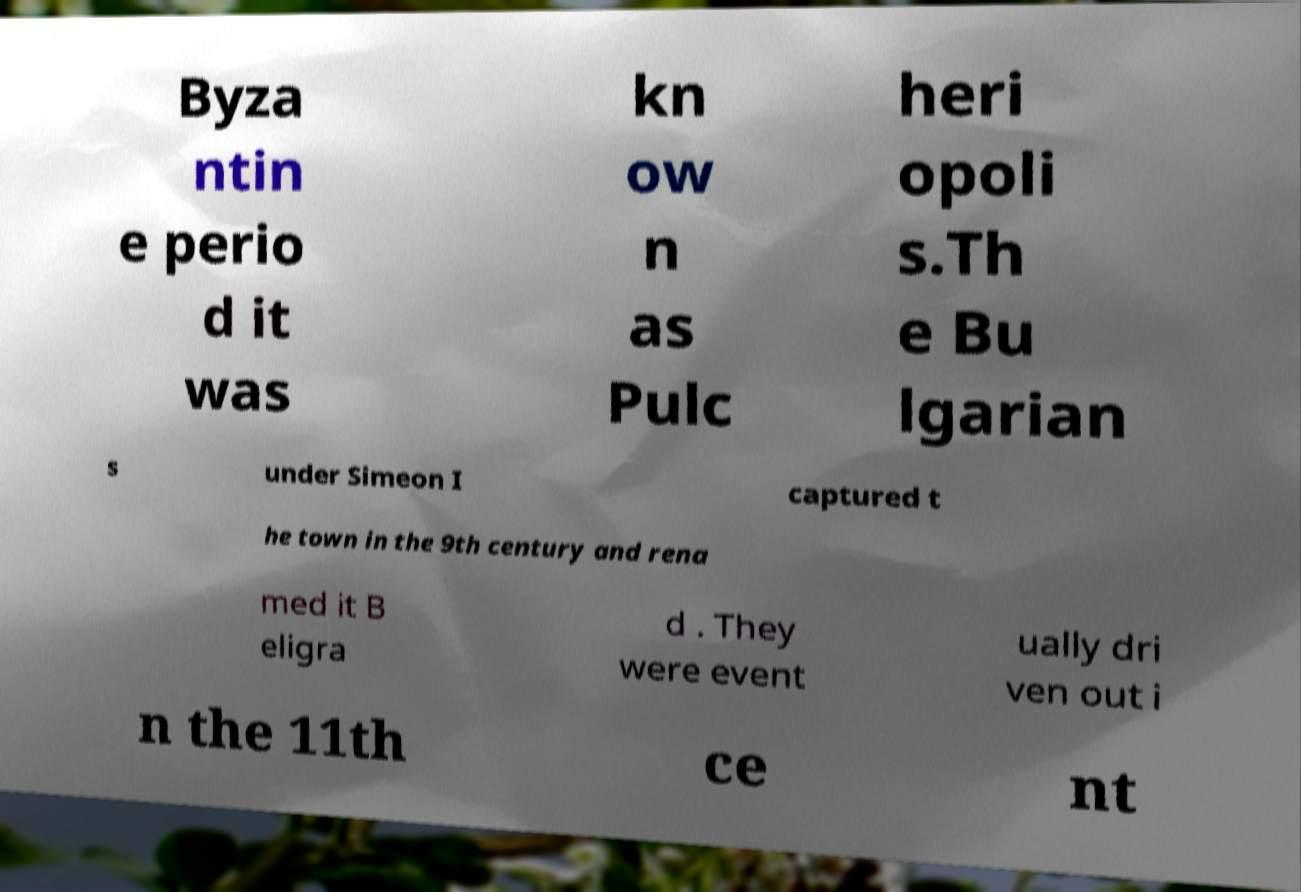Please read and relay the text visible in this image. What does it say? Byza ntin e perio d it was kn ow n as Pulc heri opoli s.Th e Bu lgarian s under Simeon I captured t he town in the 9th century and rena med it B eligra d . They were event ually dri ven out i n the 11th ce nt 